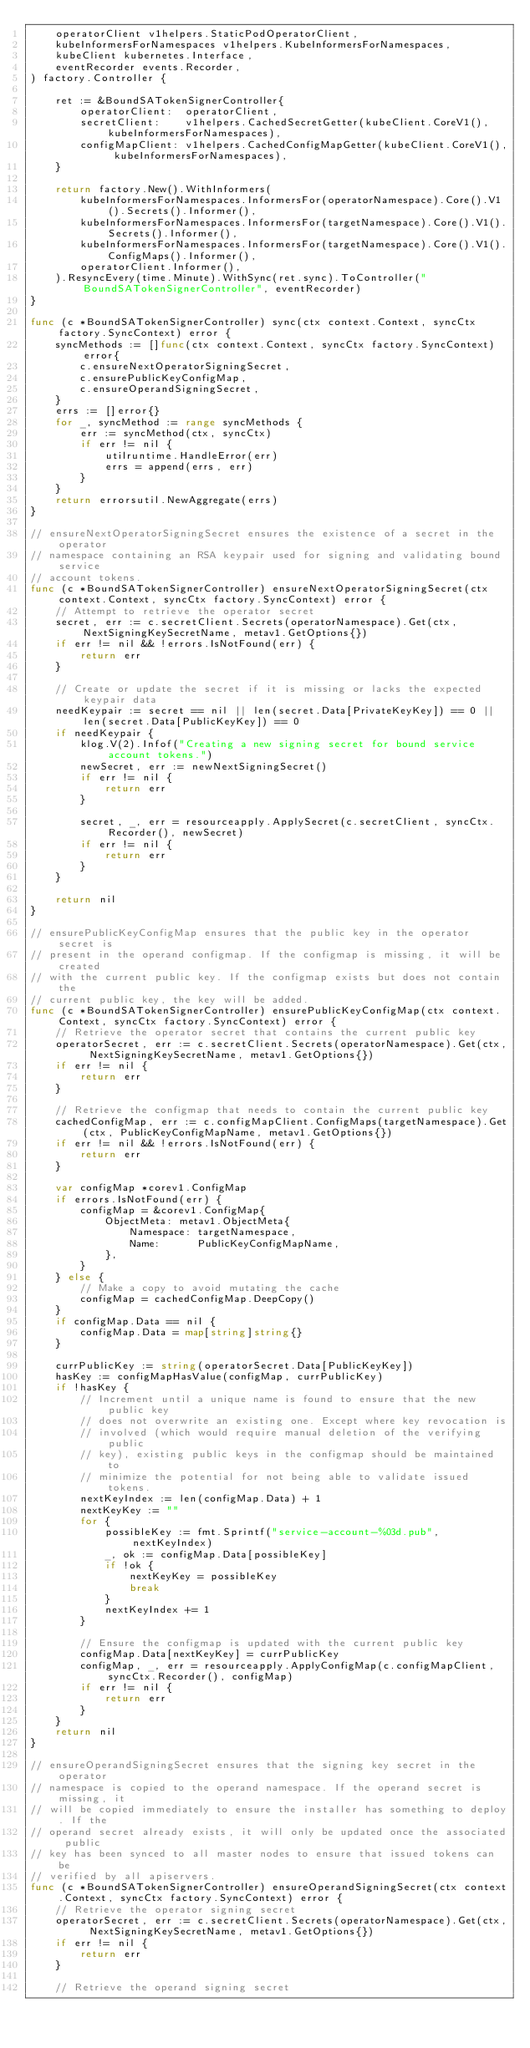<code> <loc_0><loc_0><loc_500><loc_500><_Go_>	operatorClient v1helpers.StaticPodOperatorClient,
	kubeInformersForNamespaces v1helpers.KubeInformersForNamespaces,
	kubeClient kubernetes.Interface,
	eventRecorder events.Recorder,
) factory.Controller {

	ret := &BoundSATokenSignerController{
		operatorClient:  operatorClient,
		secretClient:    v1helpers.CachedSecretGetter(kubeClient.CoreV1(), kubeInformersForNamespaces),
		configMapClient: v1helpers.CachedConfigMapGetter(kubeClient.CoreV1(), kubeInformersForNamespaces),
	}

	return factory.New().WithInformers(
		kubeInformersForNamespaces.InformersFor(operatorNamespace).Core().V1().Secrets().Informer(),
		kubeInformersForNamespaces.InformersFor(targetNamespace).Core().V1().Secrets().Informer(),
		kubeInformersForNamespaces.InformersFor(targetNamespace).Core().V1().ConfigMaps().Informer(),
		operatorClient.Informer(),
	).ResyncEvery(time.Minute).WithSync(ret.sync).ToController("BoundSATokenSignerController", eventRecorder)
}

func (c *BoundSATokenSignerController) sync(ctx context.Context, syncCtx factory.SyncContext) error {
	syncMethods := []func(ctx context.Context, syncCtx factory.SyncContext) error{
		c.ensureNextOperatorSigningSecret,
		c.ensurePublicKeyConfigMap,
		c.ensureOperandSigningSecret,
	}
	errs := []error{}
	for _, syncMethod := range syncMethods {
		err := syncMethod(ctx, syncCtx)
		if err != nil {
			utilruntime.HandleError(err)
			errs = append(errs, err)
		}
	}
	return errorsutil.NewAggregate(errs)
}

// ensureNextOperatorSigningSecret ensures the existence of a secret in the operator
// namespace containing an RSA keypair used for signing and validating bound service
// account tokens.
func (c *BoundSATokenSignerController) ensureNextOperatorSigningSecret(ctx context.Context, syncCtx factory.SyncContext) error {
	// Attempt to retrieve the operator secret
	secret, err := c.secretClient.Secrets(operatorNamespace).Get(ctx, NextSigningKeySecretName, metav1.GetOptions{})
	if err != nil && !errors.IsNotFound(err) {
		return err
	}

	// Create or update the secret if it is missing or lacks the expected keypair data
	needKeypair := secret == nil || len(secret.Data[PrivateKeyKey]) == 0 || len(secret.Data[PublicKeyKey]) == 0
	if needKeypair {
		klog.V(2).Infof("Creating a new signing secret for bound service account tokens.")
		newSecret, err := newNextSigningSecret()
		if err != nil {
			return err
		}

		secret, _, err = resourceapply.ApplySecret(c.secretClient, syncCtx.Recorder(), newSecret)
		if err != nil {
			return err
		}
	}

	return nil
}

// ensurePublicKeyConfigMap ensures that the public key in the operator secret is
// present in the operand configmap. If the configmap is missing, it will be created
// with the current public key. If the configmap exists but does not contain the
// current public key, the key will be added.
func (c *BoundSATokenSignerController) ensurePublicKeyConfigMap(ctx context.Context, syncCtx factory.SyncContext) error {
	// Retrieve the operator secret that contains the current public key
	operatorSecret, err := c.secretClient.Secrets(operatorNamespace).Get(ctx, NextSigningKeySecretName, metav1.GetOptions{})
	if err != nil {
		return err
	}

	// Retrieve the configmap that needs to contain the current public key
	cachedConfigMap, err := c.configMapClient.ConfigMaps(targetNamespace).Get(ctx, PublicKeyConfigMapName, metav1.GetOptions{})
	if err != nil && !errors.IsNotFound(err) {
		return err
	}

	var configMap *corev1.ConfigMap
	if errors.IsNotFound(err) {
		configMap = &corev1.ConfigMap{
			ObjectMeta: metav1.ObjectMeta{
				Namespace: targetNamespace,
				Name:      PublicKeyConfigMapName,
			},
		}
	} else {
		// Make a copy to avoid mutating the cache
		configMap = cachedConfigMap.DeepCopy()
	}
	if configMap.Data == nil {
		configMap.Data = map[string]string{}
	}

	currPublicKey := string(operatorSecret.Data[PublicKeyKey])
	hasKey := configMapHasValue(configMap, currPublicKey)
	if !hasKey {
		// Increment until a unique name is found to ensure that the new public key
		// does not overwrite an existing one. Except where key revocation is
		// involved (which would require manual deletion of the verifying public
		// key), existing public keys in the configmap should be maintained to
		// minimize the potential for not being able to validate issued tokens.
		nextKeyIndex := len(configMap.Data) + 1
		nextKeyKey := ""
		for {
			possibleKey := fmt.Sprintf("service-account-%03d.pub", nextKeyIndex)
			_, ok := configMap.Data[possibleKey]
			if !ok {
				nextKeyKey = possibleKey
				break
			}
			nextKeyIndex += 1
		}

		// Ensure the configmap is updated with the current public key
		configMap.Data[nextKeyKey] = currPublicKey
		configMap, _, err = resourceapply.ApplyConfigMap(c.configMapClient, syncCtx.Recorder(), configMap)
		if err != nil {
			return err
		}
	}
	return nil
}

// ensureOperandSigningSecret ensures that the signing key secret in the operator
// namespace is copied to the operand namespace. If the operand secret is missing, it
// will be copied immediately to ensure the installer has something to deploy. If the
// operand secret already exists, it will only be updated once the associated public
// key has been synced to all master nodes to ensure that issued tokens can be
// verified by all apiservers.
func (c *BoundSATokenSignerController) ensureOperandSigningSecret(ctx context.Context, syncCtx factory.SyncContext) error {
	// Retrieve the operator signing secret
	operatorSecret, err := c.secretClient.Secrets(operatorNamespace).Get(ctx, NextSigningKeySecretName, metav1.GetOptions{})
	if err != nil {
		return err
	}

	// Retrieve the operand signing secret</code> 